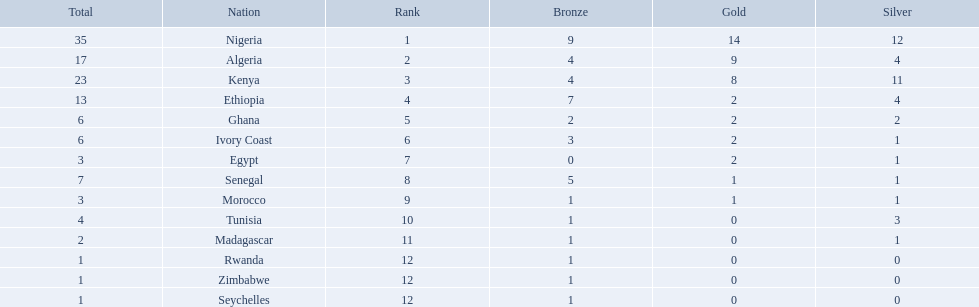Which nations competed in the 1989 african championships in athletics? Nigeria, Algeria, Kenya, Ethiopia, Ghana, Ivory Coast, Egypt, Senegal, Morocco, Tunisia, Madagascar, Rwanda, Zimbabwe, Seychelles. Of these nations, which earned 0 bronze medals? Egypt. 